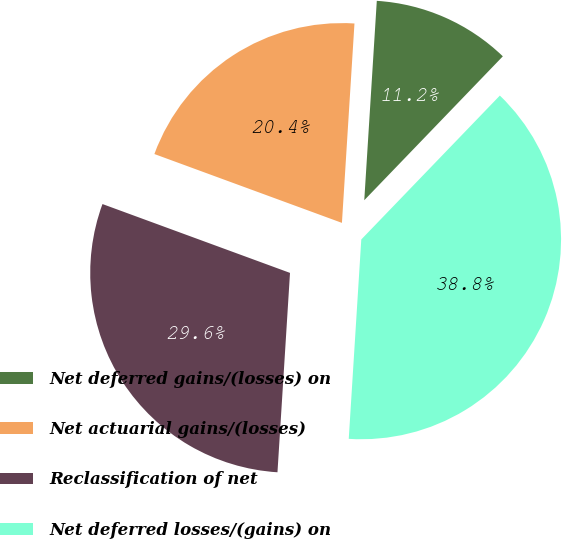Convert chart to OTSL. <chart><loc_0><loc_0><loc_500><loc_500><pie_chart><fcel>Net deferred gains/(losses) on<fcel>Net actuarial gains/(losses)<fcel>Reclassification of net<fcel>Net deferred losses/(gains) on<nl><fcel>11.2%<fcel>20.4%<fcel>29.6%<fcel>38.8%<nl></chart> 